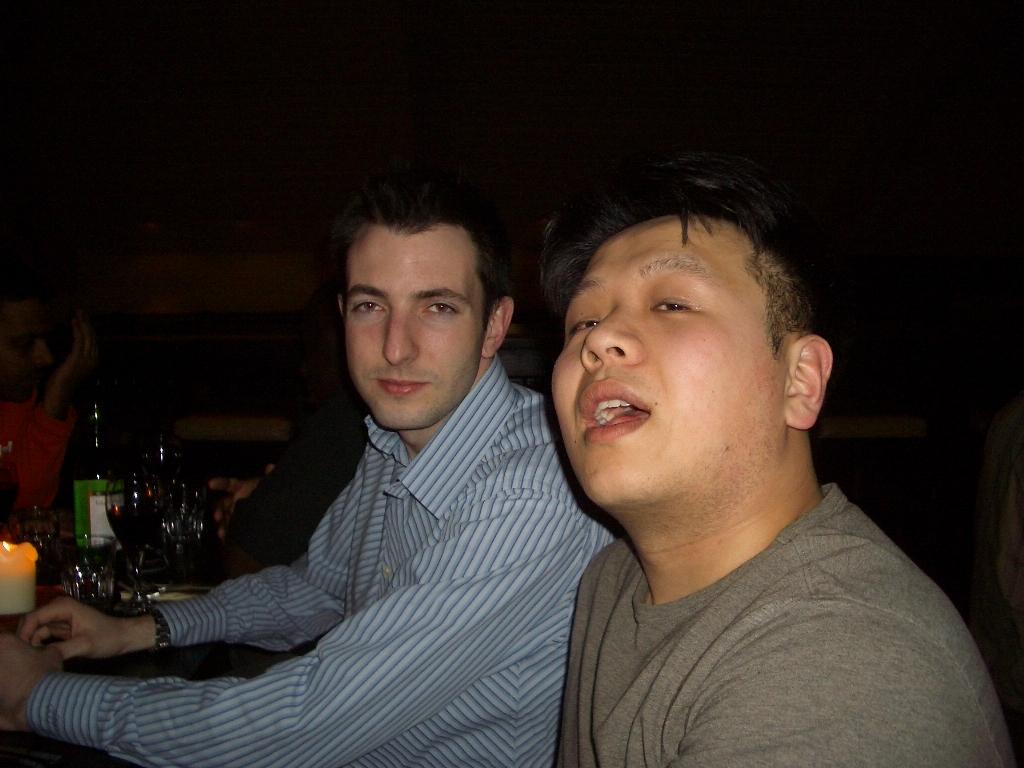How would you summarize this image in a sentence or two? In this image I can see the group of people sitting in-front of the table. These people are wearing the different color dresses. On the table I can see the candle, glasses and the bottle. And there is a black background. 